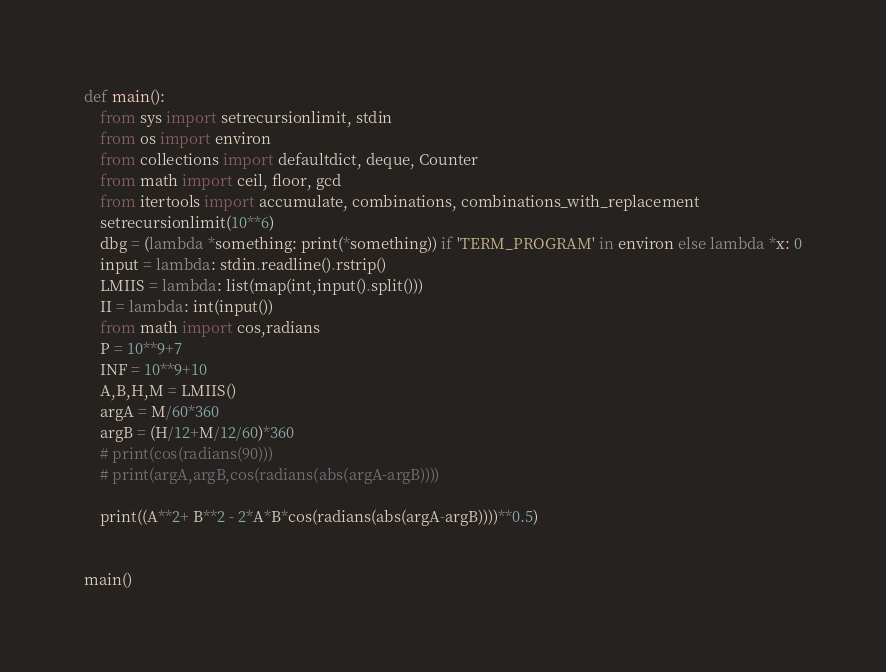Convert code to text. <code><loc_0><loc_0><loc_500><loc_500><_Python_>def main():
    from sys import setrecursionlimit, stdin
    from os import environ
    from collections import defaultdict, deque, Counter
    from math import ceil, floor, gcd
    from itertools import accumulate, combinations, combinations_with_replacement
    setrecursionlimit(10**6)
    dbg = (lambda *something: print(*something)) if 'TERM_PROGRAM' in environ else lambda *x: 0
    input = lambda: stdin.readline().rstrip()
    LMIIS = lambda: list(map(int,input().split()))
    II = lambda: int(input())
    from math import cos,radians
    P = 10**9+7
    INF = 10**9+10
    A,B,H,M = LMIIS()
    argA = M/60*360
    argB = (H/12+M/12/60)*360
    # print(cos(radians(90)))
    # print(argA,argB,cos(radians(abs(argA-argB))))

    print((A**2+ B**2 - 2*A*B*cos(radians(abs(argA-argB))))**0.5)

    
main()</code> 